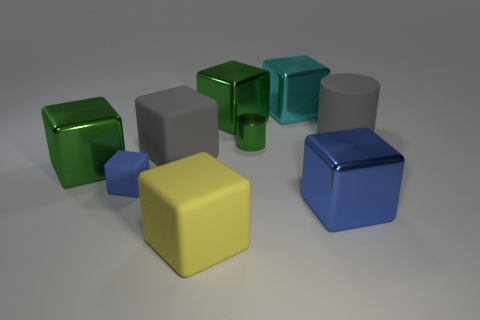Subtract all cyan cubes. How many cubes are left? 6 Subtract all small matte cubes. How many cubes are left? 6 Subtract all yellow blocks. Subtract all brown cylinders. How many blocks are left? 6 Subtract all cylinders. How many objects are left? 7 Add 4 yellow things. How many yellow things are left? 5 Add 8 brown rubber things. How many brown rubber things exist? 8 Subtract 0 red cylinders. How many objects are left? 9 Subtract all big metallic objects. Subtract all large rubber cylinders. How many objects are left? 4 